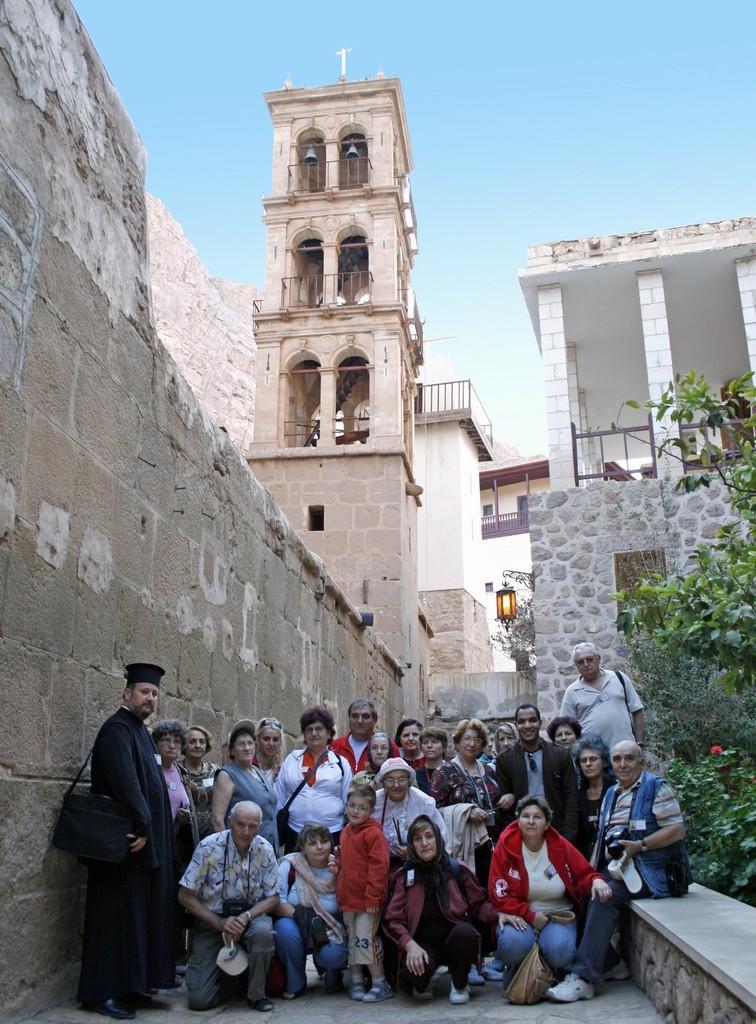Please provide a concise description of this image. In this image we can see people sitting on the floor and some are standing on the floor. In the background we can see buildings, electric lights, trees, plants and sky. 